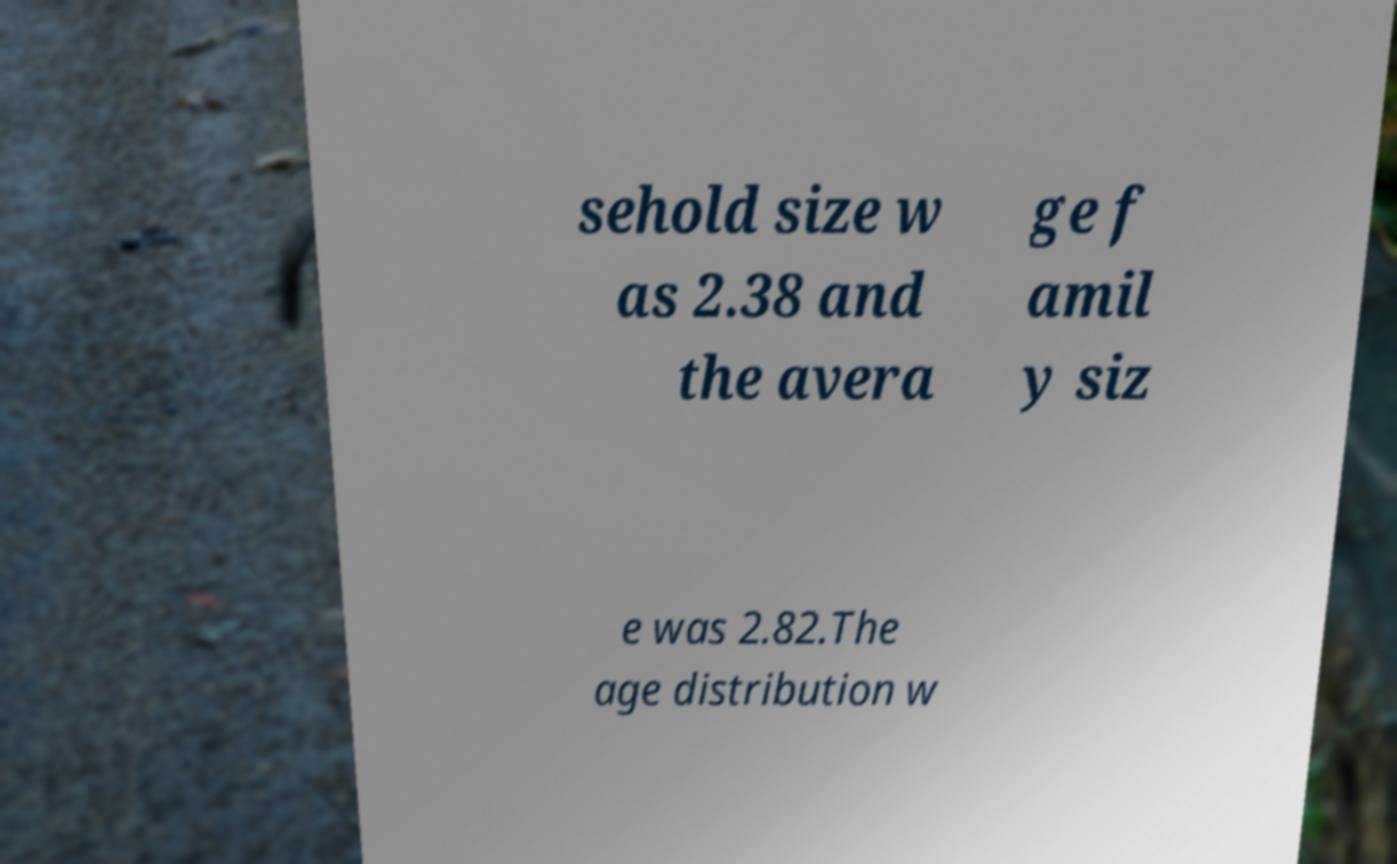There's text embedded in this image that I need extracted. Can you transcribe it verbatim? sehold size w as 2.38 and the avera ge f amil y siz e was 2.82.The age distribution w 